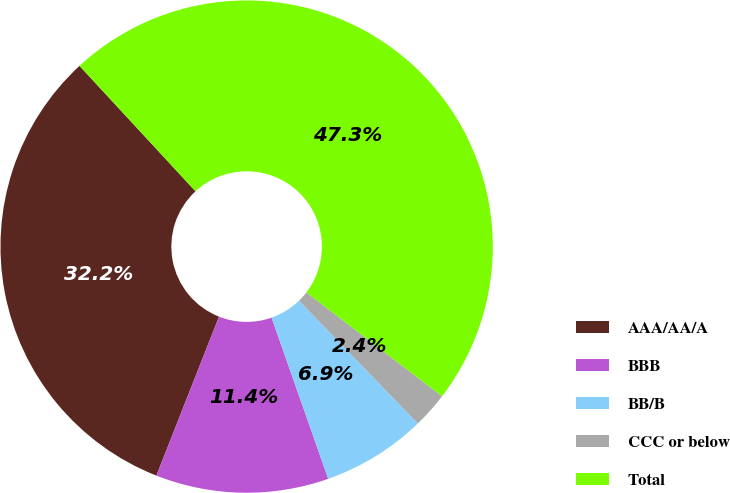Convert chart to OTSL. <chart><loc_0><loc_0><loc_500><loc_500><pie_chart><fcel>AAA/AA/A<fcel>BBB<fcel>BB/B<fcel>CCC or below<fcel>Total<nl><fcel>32.15%<fcel>11.35%<fcel>6.86%<fcel>2.36%<fcel>47.28%<nl></chart> 